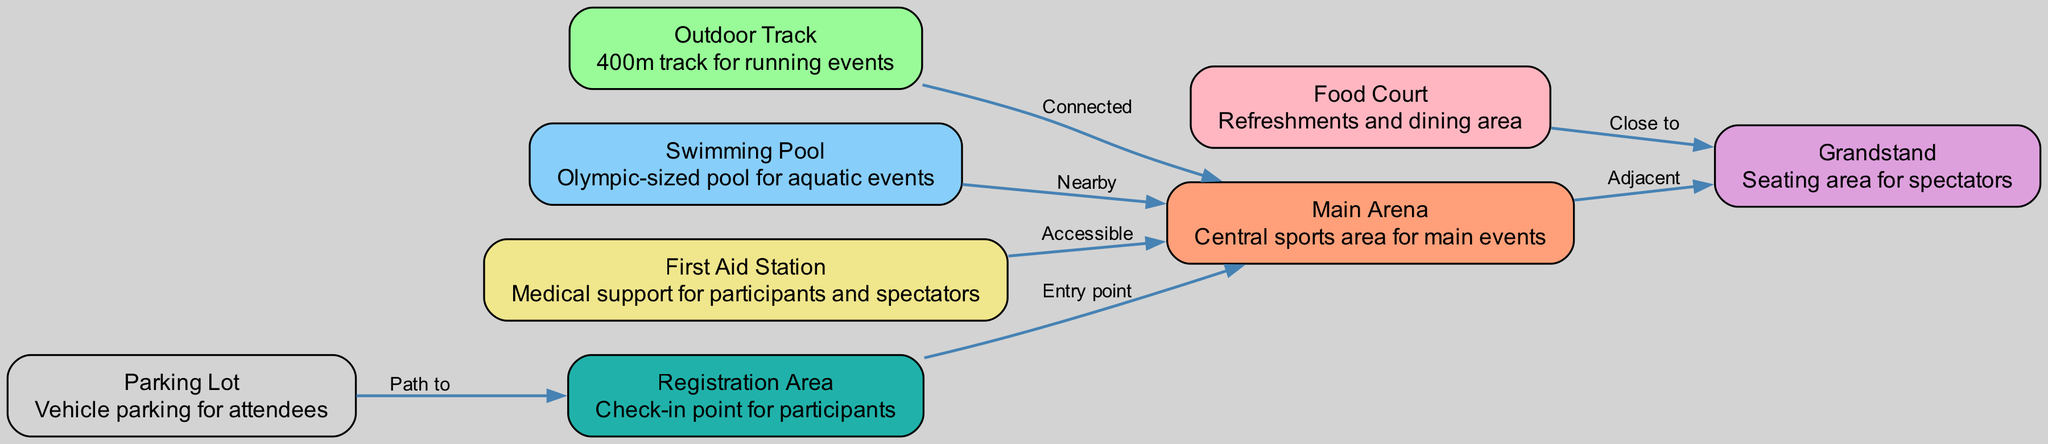What is the main purpose of the "Main Arena"? The "Main Arena" is described as the "Central sports area for main events", indicating that it serves as the focal point for the athletic activities during the charity event.
Answer: Central sports area for main events How many support facilities are indicated in the diagram? The diagram lists three support facilities: "First Aid Station", "Registration Area", and "Food Court". Counting these gives a total of three support facilities.
Answer: Three What is the connection between the "Parking Lot" and the "Registration Area"? The diagram specifies that there is a "Path to" relationship from the "Parking Lot" to the "Registration Area", indicating that attendees must walk this path to reach the registration area after parking.
Answer: Path to Which sports area is closest to the "Grandstand"? The diagram indicates that the "Food Court" is described as "Close to" the "Grandstand", making this area the closest to the spectator seating.
Answer: Food Court Is the "Swimming Pool" directly connected to the "Main Arena"? The diagram specifies that the "Swimming Pool" is "Nearby" the "Main Arena" but does not indicate a direct connection, as "Nearby" suggests proximity without a direct access link.
Answer: No What is the primary function of the "First Aid Station"? The "First Aid Station" is described as providing "Medical support for participants and spectators", indicating its main function is health and safety during the event.
Answer: Medical support for participants and spectators How many total areas are defined in the diagram? The diagram includes a total of eight nodes, which represent different areas, including sports areas, spectator zones, and support facilities. Counting these gives a total of eight distinct areas.
Answer: Eight What type of layout does the "Outdoor Track" have in relation to other sports areas? The "Outdoor Track" is described as being "Connected" to the "Main Arena", indicating a direct relationship where the track is part of the broader event layout facilitating running events.
Answer: Connected 